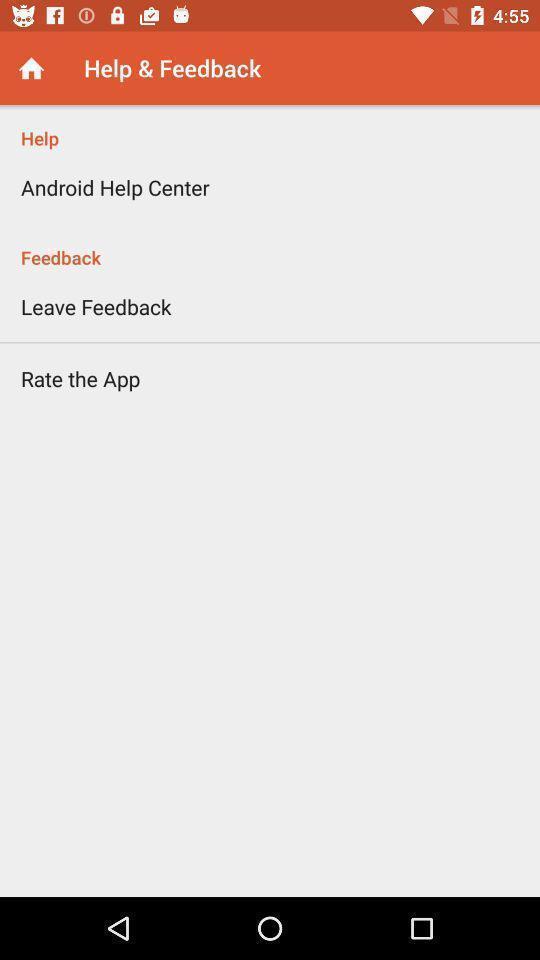Provide a description of this screenshot. Screen displaying the help page. 